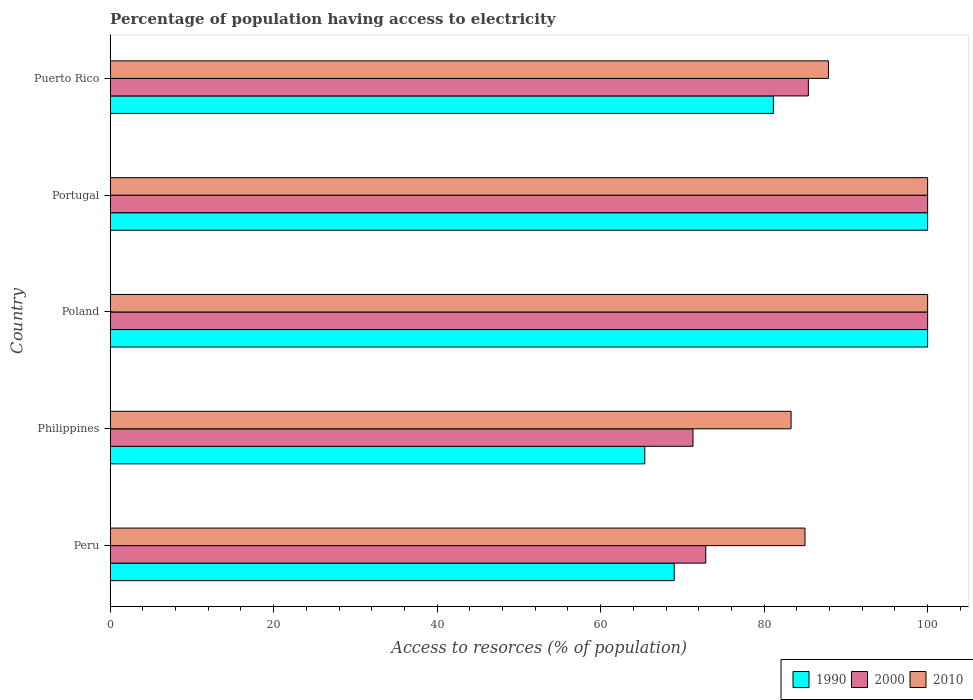How many different coloured bars are there?
Make the answer very short. 3. Are the number of bars on each tick of the Y-axis equal?
Keep it short and to the point. Yes. How many bars are there on the 5th tick from the top?
Your answer should be very brief. 3. How many bars are there on the 3rd tick from the bottom?
Offer a very short reply. 3. In how many cases, is the number of bars for a given country not equal to the number of legend labels?
Your answer should be compact. 0. What is the percentage of population having access to electricity in 2010 in Poland?
Ensure brevity in your answer.  100. Across all countries, what is the maximum percentage of population having access to electricity in 2000?
Ensure brevity in your answer.  100. Across all countries, what is the minimum percentage of population having access to electricity in 2000?
Your answer should be compact. 71.3. In which country was the percentage of population having access to electricity in 1990 minimum?
Offer a very short reply. Philippines. What is the total percentage of population having access to electricity in 2000 in the graph?
Give a very brief answer. 429.57. What is the difference between the percentage of population having access to electricity in 1990 in Peru and that in Puerto Rico?
Ensure brevity in your answer.  -12.14. What is the difference between the percentage of population having access to electricity in 2010 in Puerto Rico and the percentage of population having access to electricity in 2000 in Portugal?
Offer a terse response. -12.13. What is the average percentage of population having access to electricity in 1990 per country?
Offer a very short reply. 83.11. In how many countries, is the percentage of population having access to electricity in 2000 greater than 84 %?
Your answer should be very brief. 3. What is the ratio of the percentage of population having access to electricity in 1990 in Peru to that in Poland?
Keep it short and to the point. 0.69. Is the difference between the percentage of population having access to electricity in 2000 in Philippines and Poland greater than the difference between the percentage of population having access to electricity in 2010 in Philippines and Poland?
Offer a terse response. No. What is the difference between the highest and the second highest percentage of population having access to electricity in 1990?
Offer a very short reply. 0. What is the difference between the highest and the lowest percentage of population having access to electricity in 2010?
Provide a succinct answer. 16.7. In how many countries, is the percentage of population having access to electricity in 1990 greater than the average percentage of population having access to electricity in 1990 taken over all countries?
Ensure brevity in your answer.  2. Is the sum of the percentage of population having access to electricity in 2010 in Peru and Poland greater than the maximum percentage of population having access to electricity in 1990 across all countries?
Your response must be concise. Yes. What does the 2nd bar from the top in Portugal represents?
Make the answer very short. 2000. Is it the case that in every country, the sum of the percentage of population having access to electricity in 2010 and percentage of population having access to electricity in 2000 is greater than the percentage of population having access to electricity in 1990?
Offer a very short reply. Yes. How many bars are there?
Your response must be concise. 15. How many countries are there in the graph?
Ensure brevity in your answer.  5. What is the difference between two consecutive major ticks on the X-axis?
Your response must be concise. 20. Are the values on the major ticks of X-axis written in scientific E-notation?
Your answer should be very brief. No. Does the graph contain grids?
Make the answer very short. No. What is the title of the graph?
Your answer should be very brief. Percentage of population having access to electricity. Does "1979" appear as one of the legend labels in the graph?
Offer a terse response. No. What is the label or title of the X-axis?
Your response must be concise. Access to resorces (% of population). What is the label or title of the Y-axis?
Ensure brevity in your answer.  Country. What is the Access to resorces (% of population) of 2000 in Peru?
Keep it short and to the point. 72.86. What is the Access to resorces (% of population) in 1990 in Philippines?
Ensure brevity in your answer.  65.4. What is the Access to resorces (% of population) of 2000 in Philippines?
Give a very brief answer. 71.3. What is the Access to resorces (% of population) of 2010 in Philippines?
Make the answer very short. 83.3. What is the Access to resorces (% of population) in 1990 in Poland?
Keep it short and to the point. 100. What is the Access to resorces (% of population) of 1990 in Portugal?
Offer a very short reply. 100. What is the Access to resorces (% of population) in 2000 in Portugal?
Offer a very short reply. 100. What is the Access to resorces (% of population) in 1990 in Puerto Rico?
Your answer should be very brief. 81.14. What is the Access to resorces (% of population) in 2000 in Puerto Rico?
Provide a succinct answer. 85.41. What is the Access to resorces (% of population) in 2010 in Puerto Rico?
Provide a succinct answer. 87.87. Across all countries, what is the maximum Access to resorces (% of population) of 1990?
Provide a succinct answer. 100. Across all countries, what is the minimum Access to resorces (% of population) of 1990?
Offer a very short reply. 65.4. Across all countries, what is the minimum Access to resorces (% of population) in 2000?
Provide a short and direct response. 71.3. Across all countries, what is the minimum Access to resorces (% of population) in 2010?
Your response must be concise. 83.3. What is the total Access to resorces (% of population) in 1990 in the graph?
Provide a short and direct response. 415.54. What is the total Access to resorces (% of population) of 2000 in the graph?
Your response must be concise. 429.57. What is the total Access to resorces (% of population) of 2010 in the graph?
Ensure brevity in your answer.  456.17. What is the difference between the Access to resorces (% of population) in 2000 in Peru and that in Philippines?
Keep it short and to the point. 1.56. What is the difference between the Access to resorces (% of population) in 2010 in Peru and that in Philippines?
Offer a very short reply. 1.7. What is the difference between the Access to resorces (% of population) in 1990 in Peru and that in Poland?
Make the answer very short. -31. What is the difference between the Access to resorces (% of population) in 2000 in Peru and that in Poland?
Ensure brevity in your answer.  -27.14. What is the difference between the Access to resorces (% of population) of 2010 in Peru and that in Poland?
Give a very brief answer. -15. What is the difference between the Access to resorces (% of population) in 1990 in Peru and that in Portugal?
Offer a very short reply. -31. What is the difference between the Access to resorces (% of population) of 2000 in Peru and that in Portugal?
Keep it short and to the point. -27.14. What is the difference between the Access to resorces (% of population) of 2010 in Peru and that in Portugal?
Offer a very short reply. -15. What is the difference between the Access to resorces (% of population) in 1990 in Peru and that in Puerto Rico?
Give a very brief answer. -12.14. What is the difference between the Access to resorces (% of population) in 2000 in Peru and that in Puerto Rico?
Provide a succinct answer. -12.55. What is the difference between the Access to resorces (% of population) of 2010 in Peru and that in Puerto Rico?
Keep it short and to the point. -2.87. What is the difference between the Access to resorces (% of population) of 1990 in Philippines and that in Poland?
Keep it short and to the point. -34.6. What is the difference between the Access to resorces (% of population) in 2000 in Philippines and that in Poland?
Provide a succinct answer. -28.7. What is the difference between the Access to resorces (% of population) in 2010 in Philippines and that in Poland?
Make the answer very short. -16.7. What is the difference between the Access to resorces (% of population) of 1990 in Philippines and that in Portugal?
Your response must be concise. -34.6. What is the difference between the Access to resorces (% of population) of 2000 in Philippines and that in Portugal?
Give a very brief answer. -28.7. What is the difference between the Access to resorces (% of population) of 2010 in Philippines and that in Portugal?
Make the answer very short. -16.7. What is the difference between the Access to resorces (% of population) of 1990 in Philippines and that in Puerto Rico?
Keep it short and to the point. -15.74. What is the difference between the Access to resorces (% of population) in 2000 in Philippines and that in Puerto Rico?
Offer a very short reply. -14.11. What is the difference between the Access to resorces (% of population) in 2010 in Philippines and that in Puerto Rico?
Provide a succinct answer. -4.57. What is the difference between the Access to resorces (% of population) of 1990 in Poland and that in Puerto Rico?
Ensure brevity in your answer.  18.86. What is the difference between the Access to resorces (% of population) of 2000 in Poland and that in Puerto Rico?
Provide a short and direct response. 14.59. What is the difference between the Access to resorces (% of population) in 2010 in Poland and that in Puerto Rico?
Keep it short and to the point. 12.13. What is the difference between the Access to resorces (% of population) in 1990 in Portugal and that in Puerto Rico?
Keep it short and to the point. 18.86. What is the difference between the Access to resorces (% of population) in 2000 in Portugal and that in Puerto Rico?
Your answer should be very brief. 14.59. What is the difference between the Access to resorces (% of population) in 2010 in Portugal and that in Puerto Rico?
Your answer should be compact. 12.13. What is the difference between the Access to resorces (% of population) of 1990 in Peru and the Access to resorces (% of population) of 2010 in Philippines?
Give a very brief answer. -14.3. What is the difference between the Access to resorces (% of population) in 2000 in Peru and the Access to resorces (% of population) in 2010 in Philippines?
Provide a short and direct response. -10.44. What is the difference between the Access to resorces (% of population) of 1990 in Peru and the Access to resorces (% of population) of 2000 in Poland?
Offer a very short reply. -31. What is the difference between the Access to resorces (% of population) of 1990 in Peru and the Access to resorces (% of population) of 2010 in Poland?
Your answer should be very brief. -31. What is the difference between the Access to resorces (% of population) in 2000 in Peru and the Access to resorces (% of population) in 2010 in Poland?
Make the answer very short. -27.14. What is the difference between the Access to resorces (% of population) in 1990 in Peru and the Access to resorces (% of population) in 2000 in Portugal?
Provide a succinct answer. -31. What is the difference between the Access to resorces (% of population) in 1990 in Peru and the Access to resorces (% of population) in 2010 in Portugal?
Keep it short and to the point. -31. What is the difference between the Access to resorces (% of population) of 2000 in Peru and the Access to resorces (% of population) of 2010 in Portugal?
Ensure brevity in your answer.  -27.14. What is the difference between the Access to resorces (% of population) in 1990 in Peru and the Access to resorces (% of population) in 2000 in Puerto Rico?
Provide a short and direct response. -16.41. What is the difference between the Access to resorces (% of population) of 1990 in Peru and the Access to resorces (% of population) of 2010 in Puerto Rico?
Offer a terse response. -18.87. What is the difference between the Access to resorces (% of population) of 2000 in Peru and the Access to resorces (% of population) of 2010 in Puerto Rico?
Give a very brief answer. -15.01. What is the difference between the Access to resorces (% of population) in 1990 in Philippines and the Access to resorces (% of population) in 2000 in Poland?
Give a very brief answer. -34.6. What is the difference between the Access to resorces (% of population) in 1990 in Philippines and the Access to resorces (% of population) in 2010 in Poland?
Offer a terse response. -34.6. What is the difference between the Access to resorces (% of population) of 2000 in Philippines and the Access to resorces (% of population) of 2010 in Poland?
Give a very brief answer. -28.7. What is the difference between the Access to resorces (% of population) of 1990 in Philippines and the Access to resorces (% of population) of 2000 in Portugal?
Make the answer very short. -34.6. What is the difference between the Access to resorces (% of population) of 1990 in Philippines and the Access to resorces (% of population) of 2010 in Portugal?
Provide a short and direct response. -34.6. What is the difference between the Access to resorces (% of population) of 2000 in Philippines and the Access to resorces (% of population) of 2010 in Portugal?
Make the answer very short. -28.7. What is the difference between the Access to resorces (% of population) of 1990 in Philippines and the Access to resorces (% of population) of 2000 in Puerto Rico?
Offer a very short reply. -20.01. What is the difference between the Access to resorces (% of population) in 1990 in Philippines and the Access to resorces (% of population) in 2010 in Puerto Rico?
Keep it short and to the point. -22.47. What is the difference between the Access to resorces (% of population) of 2000 in Philippines and the Access to resorces (% of population) of 2010 in Puerto Rico?
Provide a short and direct response. -16.57. What is the difference between the Access to resorces (% of population) of 1990 in Poland and the Access to resorces (% of population) of 2000 in Portugal?
Provide a succinct answer. 0. What is the difference between the Access to resorces (% of population) in 1990 in Poland and the Access to resorces (% of population) in 2000 in Puerto Rico?
Offer a terse response. 14.59. What is the difference between the Access to resorces (% of population) in 1990 in Poland and the Access to resorces (% of population) in 2010 in Puerto Rico?
Provide a short and direct response. 12.13. What is the difference between the Access to resorces (% of population) in 2000 in Poland and the Access to resorces (% of population) in 2010 in Puerto Rico?
Ensure brevity in your answer.  12.13. What is the difference between the Access to resorces (% of population) of 1990 in Portugal and the Access to resorces (% of population) of 2000 in Puerto Rico?
Give a very brief answer. 14.59. What is the difference between the Access to resorces (% of population) of 1990 in Portugal and the Access to resorces (% of population) of 2010 in Puerto Rico?
Your response must be concise. 12.13. What is the difference between the Access to resorces (% of population) of 2000 in Portugal and the Access to resorces (% of population) of 2010 in Puerto Rico?
Make the answer very short. 12.13. What is the average Access to resorces (% of population) in 1990 per country?
Offer a terse response. 83.11. What is the average Access to resorces (% of population) of 2000 per country?
Your response must be concise. 85.91. What is the average Access to resorces (% of population) of 2010 per country?
Your answer should be compact. 91.23. What is the difference between the Access to resorces (% of population) in 1990 and Access to resorces (% of population) in 2000 in Peru?
Your response must be concise. -3.86. What is the difference between the Access to resorces (% of population) in 1990 and Access to resorces (% of population) in 2010 in Peru?
Provide a short and direct response. -16. What is the difference between the Access to resorces (% of population) in 2000 and Access to resorces (% of population) in 2010 in Peru?
Your response must be concise. -12.14. What is the difference between the Access to resorces (% of population) in 1990 and Access to resorces (% of population) in 2010 in Philippines?
Offer a terse response. -17.9. What is the difference between the Access to resorces (% of population) in 2000 and Access to resorces (% of population) in 2010 in Poland?
Provide a short and direct response. 0. What is the difference between the Access to resorces (% of population) of 1990 and Access to resorces (% of population) of 2010 in Portugal?
Keep it short and to the point. 0. What is the difference between the Access to resorces (% of population) of 2000 and Access to resorces (% of population) of 2010 in Portugal?
Offer a terse response. 0. What is the difference between the Access to resorces (% of population) of 1990 and Access to resorces (% of population) of 2000 in Puerto Rico?
Offer a terse response. -4.28. What is the difference between the Access to resorces (% of population) in 1990 and Access to resorces (% of population) in 2010 in Puerto Rico?
Provide a short and direct response. -6.74. What is the difference between the Access to resorces (% of population) of 2000 and Access to resorces (% of population) of 2010 in Puerto Rico?
Your answer should be compact. -2.46. What is the ratio of the Access to resorces (% of population) in 1990 in Peru to that in Philippines?
Provide a short and direct response. 1.05. What is the ratio of the Access to resorces (% of population) in 2000 in Peru to that in Philippines?
Your answer should be compact. 1.02. What is the ratio of the Access to resorces (% of population) of 2010 in Peru to that in Philippines?
Ensure brevity in your answer.  1.02. What is the ratio of the Access to resorces (% of population) of 1990 in Peru to that in Poland?
Offer a terse response. 0.69. What is the ratio of the Access to resorces (% of population) in 2000 in Peru to that in Poland?
Your answer should be compact. 0.73. What is the ratio of the Access to resorces (% of population) in 2010 in Peru to that in Poland?
Provide a short and direct response. 0.85. What is the ratio of the Access to resorces (% of population) of 1990 in Peru to that in Portugal?
Keep it short and to the point. 0.69. What is the ratio of the Access to resorces (% of population) in 2000 in Peru to that in Portugal?
Provide a succinct answer. 0.73. What is the ratio of the Access to resorces (% of population) in 1990 in Peru to that in Puerto Rico?
Provide a succinct answer. 0.85. What is the ratio of the Access to resorces (% of population) in 2000 in Peru to that in Puerto Rico?
Offer a very short reply. 0.85. What is the ratio of the Access to resorces (% of population) in 2010 in Peru to that in Puerto Rico?
Give a very brief answer. 0.97. What is the ratio of the Access to resorces (% of population) of 1990 in Philippines to that in Poland?
Ensure brevity in your answer.  0.65. What is the ratio of the Access to resorces (% of population) in 2000 in Philippines to that in Poland?
Give a very brief answer. 0.71. What is the ratio of the Access to resorces (% of population) of 2010 in Philippines to that in Poland?
Your answer should be very brief. 0.83. What is the ratio of the Access to resorces (% of population) of 1990 in Philippines to that in Portugal?
Make the answer very short. 0.65. What is the ratio of the Access to resorces (% of population) of 2000 in Philippines to that in Portugal?
Your answer should be compact. 0.71. What is the ratio of the Access to resorces (% of population) in 2010 in Philippines to that in Portugal?
Offer a terse response. 0.83. What is the ratio of the Access to resorces (% of population) in 1990 in Philippines to that in Puerto Rico?
Offer a very short reply. 0.81. What is the ratio of the Access to resorces (% of population) in 2000 in Philippines to that in Puerto Rico?
Make the answer very short. 0.83. What is the ratio of the Access to resorces (% of population) of 2010 in Philippines to that in Puerto Rico?
Offer a very short reply. 0.95. What is the ratio of the Access to resorces (% of population) of 1990 in Poland to that in Portugal?
Provide a short and direct response. 1. What is the ratio of the Access to resorces (% of population) of 1990 in Poland to that in Puerto Rico?
Make the answer very short. 1.23. What is the ratio of the Access to resorces (% of population) of 2000 in Poland to that in Puerto Rico?
Provide a short and direct response. 1.17. What is the ratio of the Access to resorces (% of population) of 2010 in Poland to that in Puerto Rico?
Keep it short and to the point. 1.14. What is the ratio of the Access to resorces (% of population) in 1990 in Portugal to that in Puerto Rico?
Your response must be concise. 1.23. What is the ratio of the Access to resorces (% of population) in 2000 in Portugal to that in Puerto Rico?
Keep it short and to the point. 1.17. What is the ratio of the Access to resorces (% of population) in 2010 in Portugal to that in Puerto Rico?
Keep it short and to the point. 1.14. What is the difference between the highest and the second highest Access to resorces (% of population) in 2010?
Give a very brief answer. 0. What is the difference between the highest and the lowest Access to resorces (% of population) in 1990?
Provide a succinct answer. 34.6. What is the difference between the highest and the lowest Access to resorces (% of population) of 2000?
Provide a short and direct response. 28.7. What is the difference between the highest and the lowest Access to resorces (% of population) in 2010?
Make the answer very short. 16.7. 